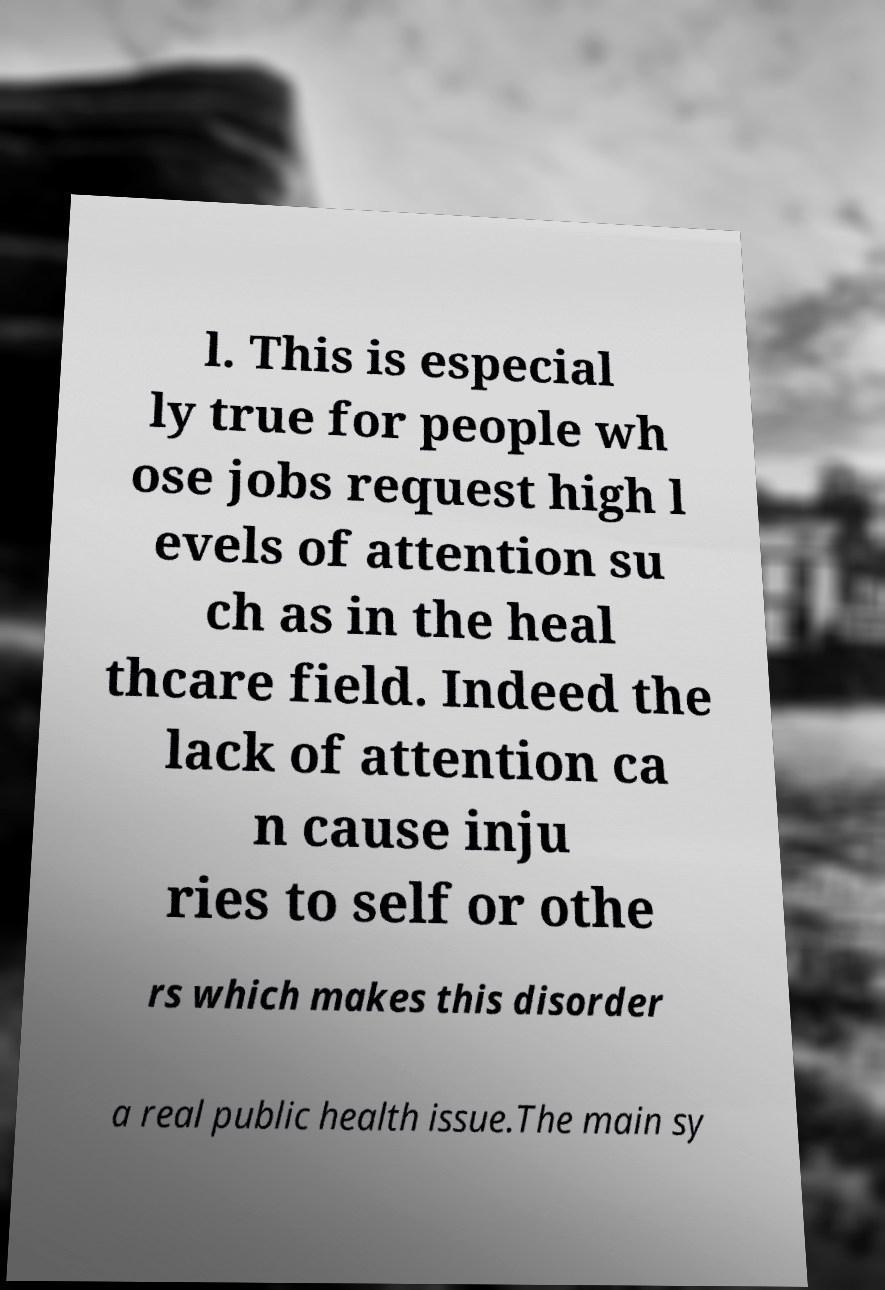Could you assist in decoding the text presented in this image and type it out clearly? l. This is especial ly true for people wh ose jobs request high l evels of attention su ch as in the heal thcare field. Indeed the lack of attention ca n cause inju ries to self or othe rs which makes this disorder a real public health issue.The main sy 